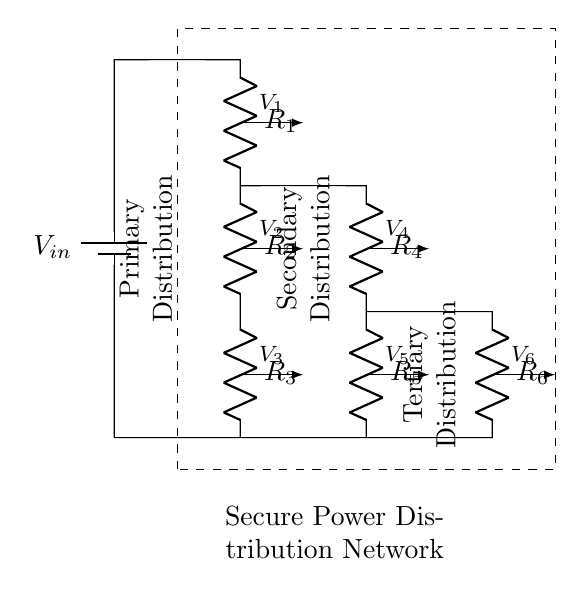What is the total number of resistors in the circuit? There are six resistors labeled R1 through R6 in the circuit diagram, summing them up gives a total of six resistors.
Answer: six What is the voltage across R1? The voltage across R1 is labeled as V1 in the circuit diagram, indicating it is the voltage drop measured across the first resistor.
Answer: V1 Which section of the circuit does R4 belong to? R4 is located in the secondary distribution section of the circuit, as indicated by its position between R3 and R5 in the schematic.
Answer: Secondary Distribution How many stages of voltage distribution are represented in the circuit? The diagram shows three distinct stages labeled primary, secondary, and tertiary distribution, leading to a total count of three stages.
Answer: three What is the role of the voltage divider in this setup? The voltage divider configuration in this setup is utilized to obtain different voltage levels (V1 to V6) across the resistors, facilitating secure power distribution for various components.
Answer: Secure power distribution What is the relationship between V2 and V4 in terms of distribution? V2 is the voltage at the end of the primary distribution stage, while V4 marks the beginning of the secondary stage, showing that V4 is derived from V2 through the voltage division.
Answer: V4 is derived from V2 What is the function of the dashed rectangle in the circuit? The dashed rectangle visually denotes the boundaries of the secure power distribution network, indicating that all components within the rectangle operate together as part of this network.
Answer: Secure Power Distribution Network 